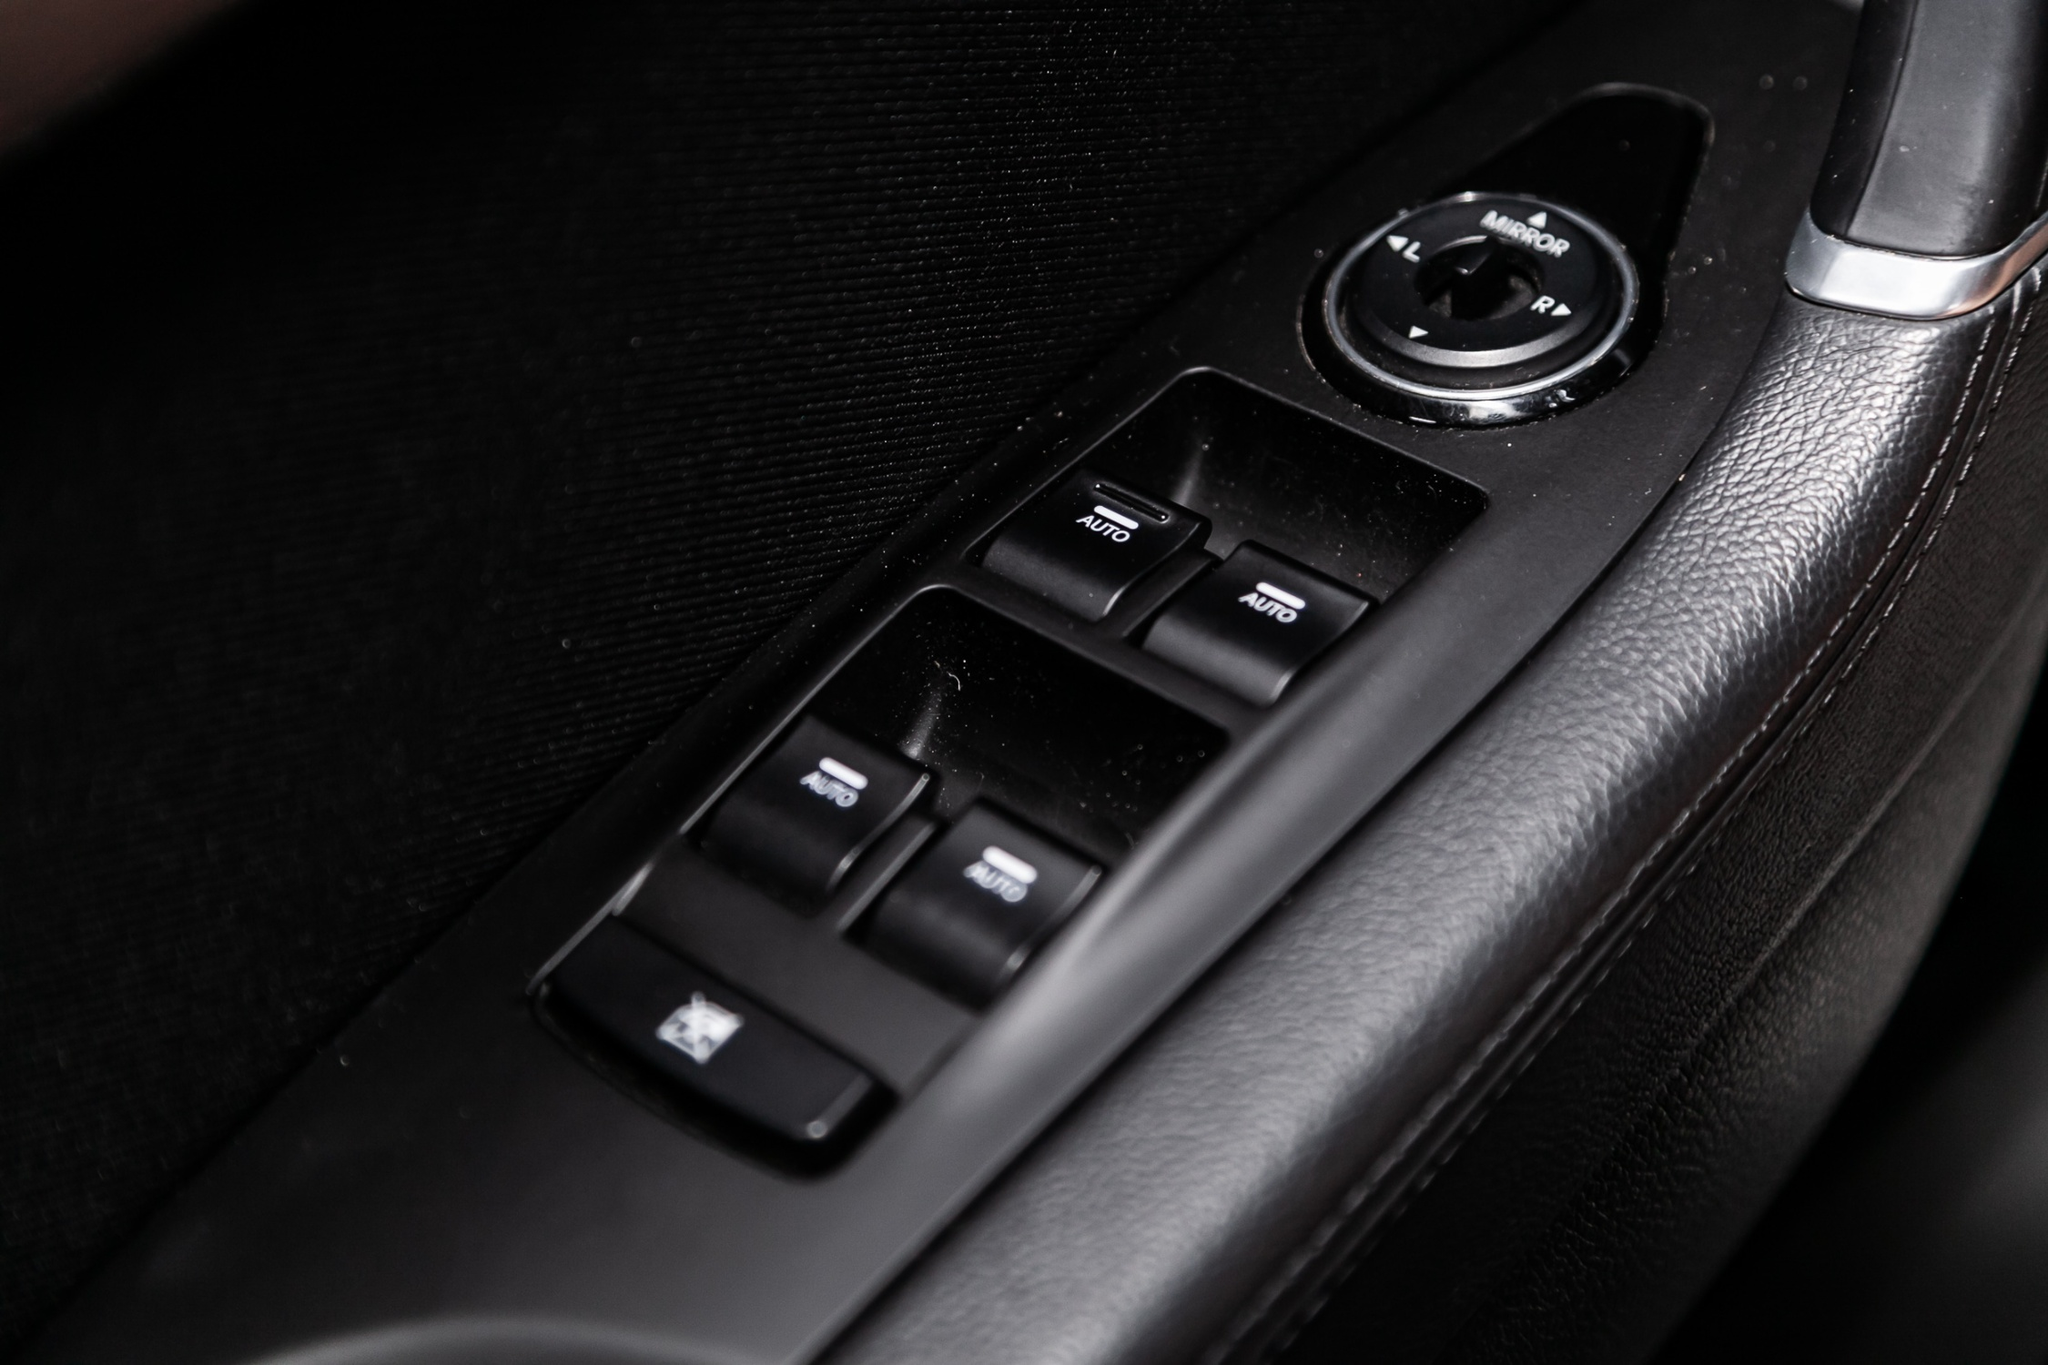Suppose this car was a futuristic vehicle with advanced AI. What additional features might the driver's side door panel include? In a futuristic vehicle enhanced by advanced AI, the driver's side door panel could feature a touch-sensitive interface with holographic buttons. These buttons could offer voice-activated controls for an even more seamless experience. You could simply say, 'Open window,' and the window would glide down automatically.

Additionally, the panel might include biometric sensing for increased security, only allowing the car to be unlocked by recognized fingerprints or retinal scans. It could also have real-time environmental monitoring, alerting the driver to any nearby obstacles or hazards with visual and auditory signals. Integrated climate control settings would allow for personalized comfort adjustments with a single touch. This technological leap would not only enhance convenience but also improve safety and user-friendliness tremendously. 